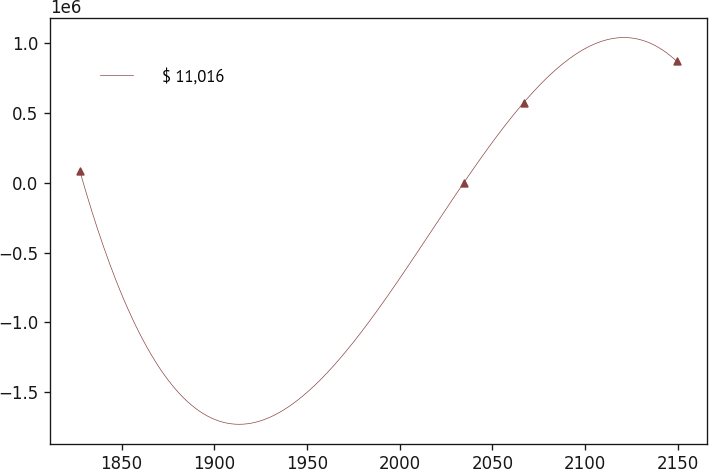Convert chart. <chart><loc_0><loc_0><loc_500><loc_500><line_chart><ecel><fcel>$ 11,016<nl><fcel>1827.45<fcel>88136.9<nl><fcel>2034.6<fcel>1125.26<nl><fcel>2066.79<fcel>573596<nl><fcel>2149.37<fcel>871241<nl></chart> 